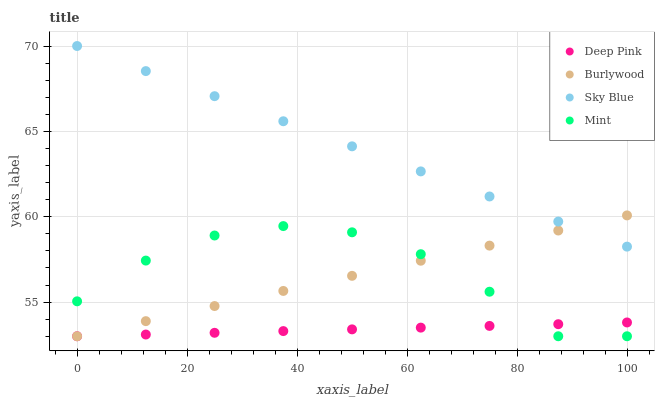Does Deep Pink have the minimum area under the curve?
Answer yes or no. Yes. Does Sky Blue have the maximum area under the curve?
Answer yes or no. Yes. Does Sky Blue have the minimum area under the curve?
Answer yes or no. No. Does Deep Pink have the maximum area under the curve?
Answer yes or no. No. Is Burlywood the smoothest?
Answer yes or no. Yes. Is Mint the roughest?
Answer yes or no. Yes. Is Sky Blue the smoothest?
Answer yes or no. No. Is Sky Blue the roughest?
Answer yes or no. No. Does Burlywood have the lowest value?
Answer yes or no. Yes. Does Sky Blue have the lowest value?
Answer yes or no. No. Does Sky Blue have the highest value?
Answer yes or no. Yes. Does Deep Pink have the highest value?
Answer yes or no. No. Is Deep Pink less than Sky Blue?
Answer yes or no. Yes. Is Sky Blue greater than Deep Pink?
Answer yes or no. Yes. Does Burlywood intersect Mint?
Answer yes or no. Yes. Is Burlywood less than Mint?
Answer yes or no. No. Is Burlywood greater than Mint?
Answer yes or no. No. Does Deep Pink intersect Sky Blue?
Answer yes or no. No. 